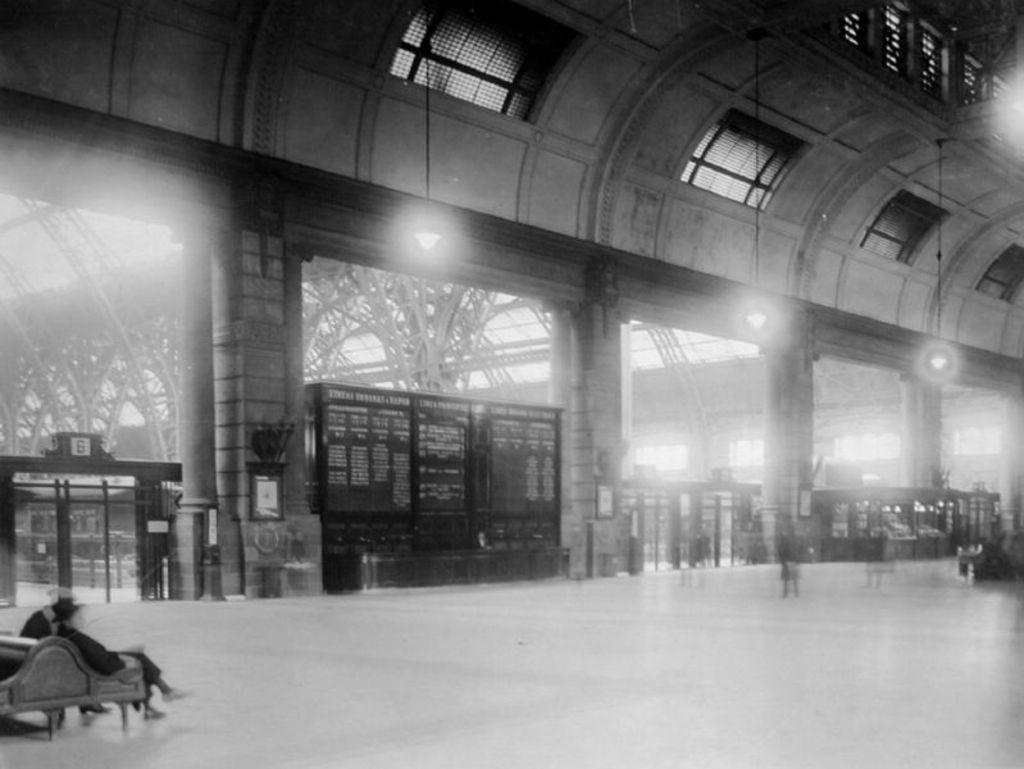What is the person in the image doing? There is a person sitting on a bench in the image. What can be seen in the background of the image? There is a wall and buildings in the background of the image. What object is located in the middle of the image? There is a board in the middle of the image. What is the surface on which the person is sitting? There is a floor at the bottom of the image. What type of soup is being served on the board in the image? There is no soup present in the image; the board is empty. 